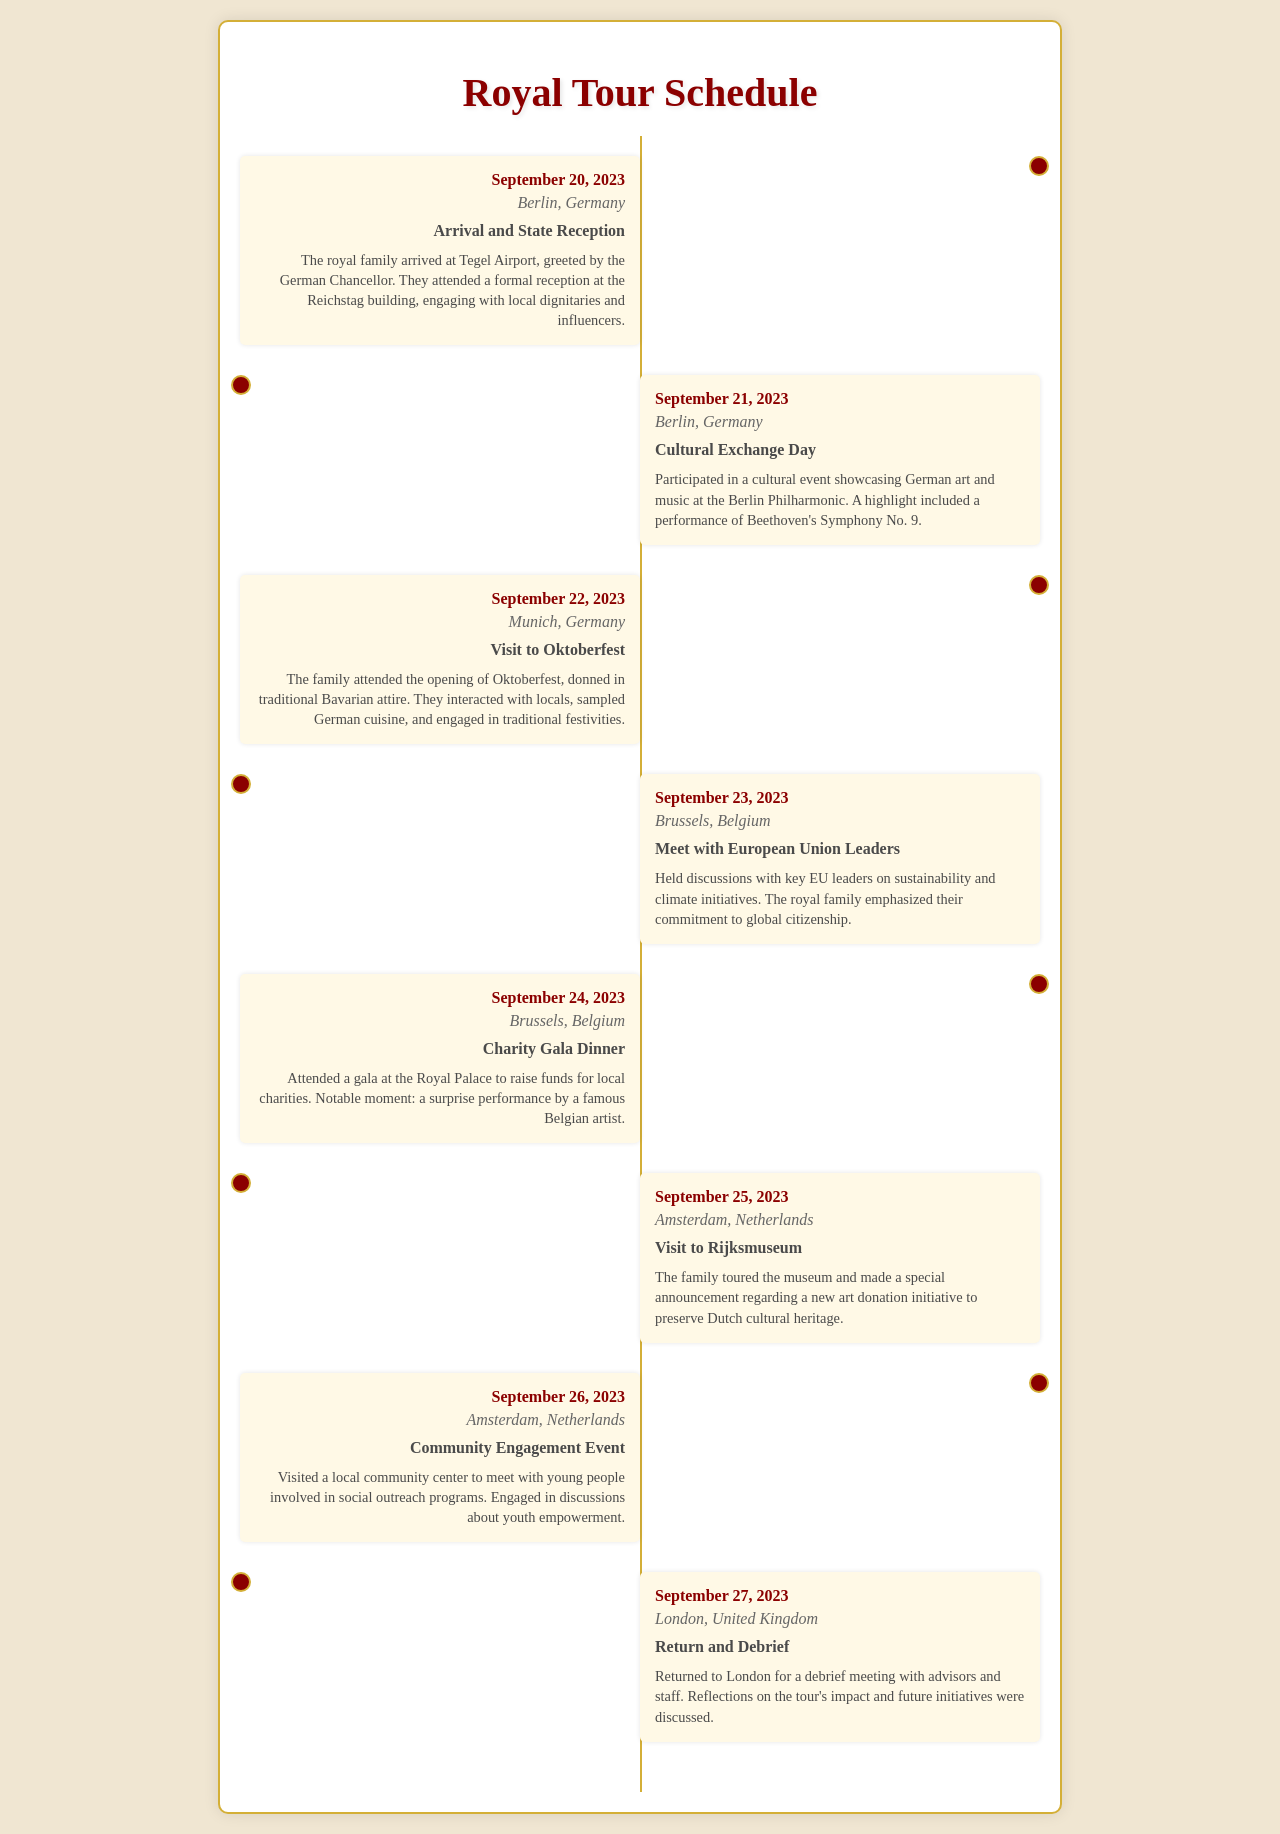What was the date of the Arrival and State Reception? The document states that the Arrival and State Reception occurred on September 20, 2023.
Answer: September 20, 2023 Which city hosted the Charity Gala Dinner? According to the schedule, the Charity Gala Dinner took place in Brussels, Belgium.
Answer: Brussels, Belgium What significant cultural event did the royal family participate in on September 21? On September 21, the royal family participated in a cultural event showcasing German art and music at the Berlin Philharmonic.
Answer: Cultural Exchange Day How many locations did the royal family visit during the tour? The document lists a total of six locations that the royal family visited throughout the tour: Berlin, Munich, Brussels, Amsterdam, and back to London.
Answer: Six What was one notable moment during the Charity Gala Dinner? A notable moment during the Charity Gala Dinner was a surprise performance by a famous Belgian artist.
Answer: Surprise performance What was the focus of the discussions on September 23? The discussions on September 23 focused on sustainability and climate initiatives with EU leaders.
Answer: Sustainability and climate initiatives In which city did the royal family don traditional Bavarian attire? The royal family donned traditional Bavarian attire in Munich, Germany, during their visit to Oktoberfest.
Answer: Munich, Germany What was announced during the visit to the Rijksmuseum? During their visit to the Rijksmuseum, the royal family made a special announcement regarding a new art donation initiative.
Answer: Art donation initiative 